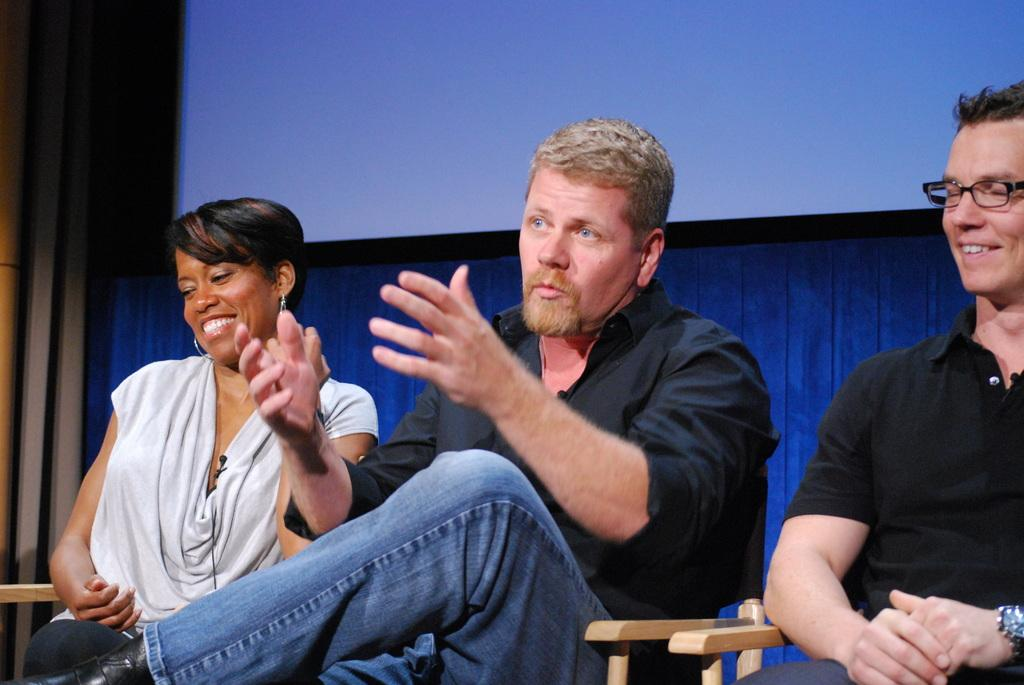How many people are in the image? There are three persons in the image. What are the persons doing in the image? The persons are sitting on chairs. What can be seen in the background of the image? There is a screen and a wall in the background of the image. What type of loaf is being offered by the person on the left in the image? There is no loaf present in the image, and no person is offering anything. 